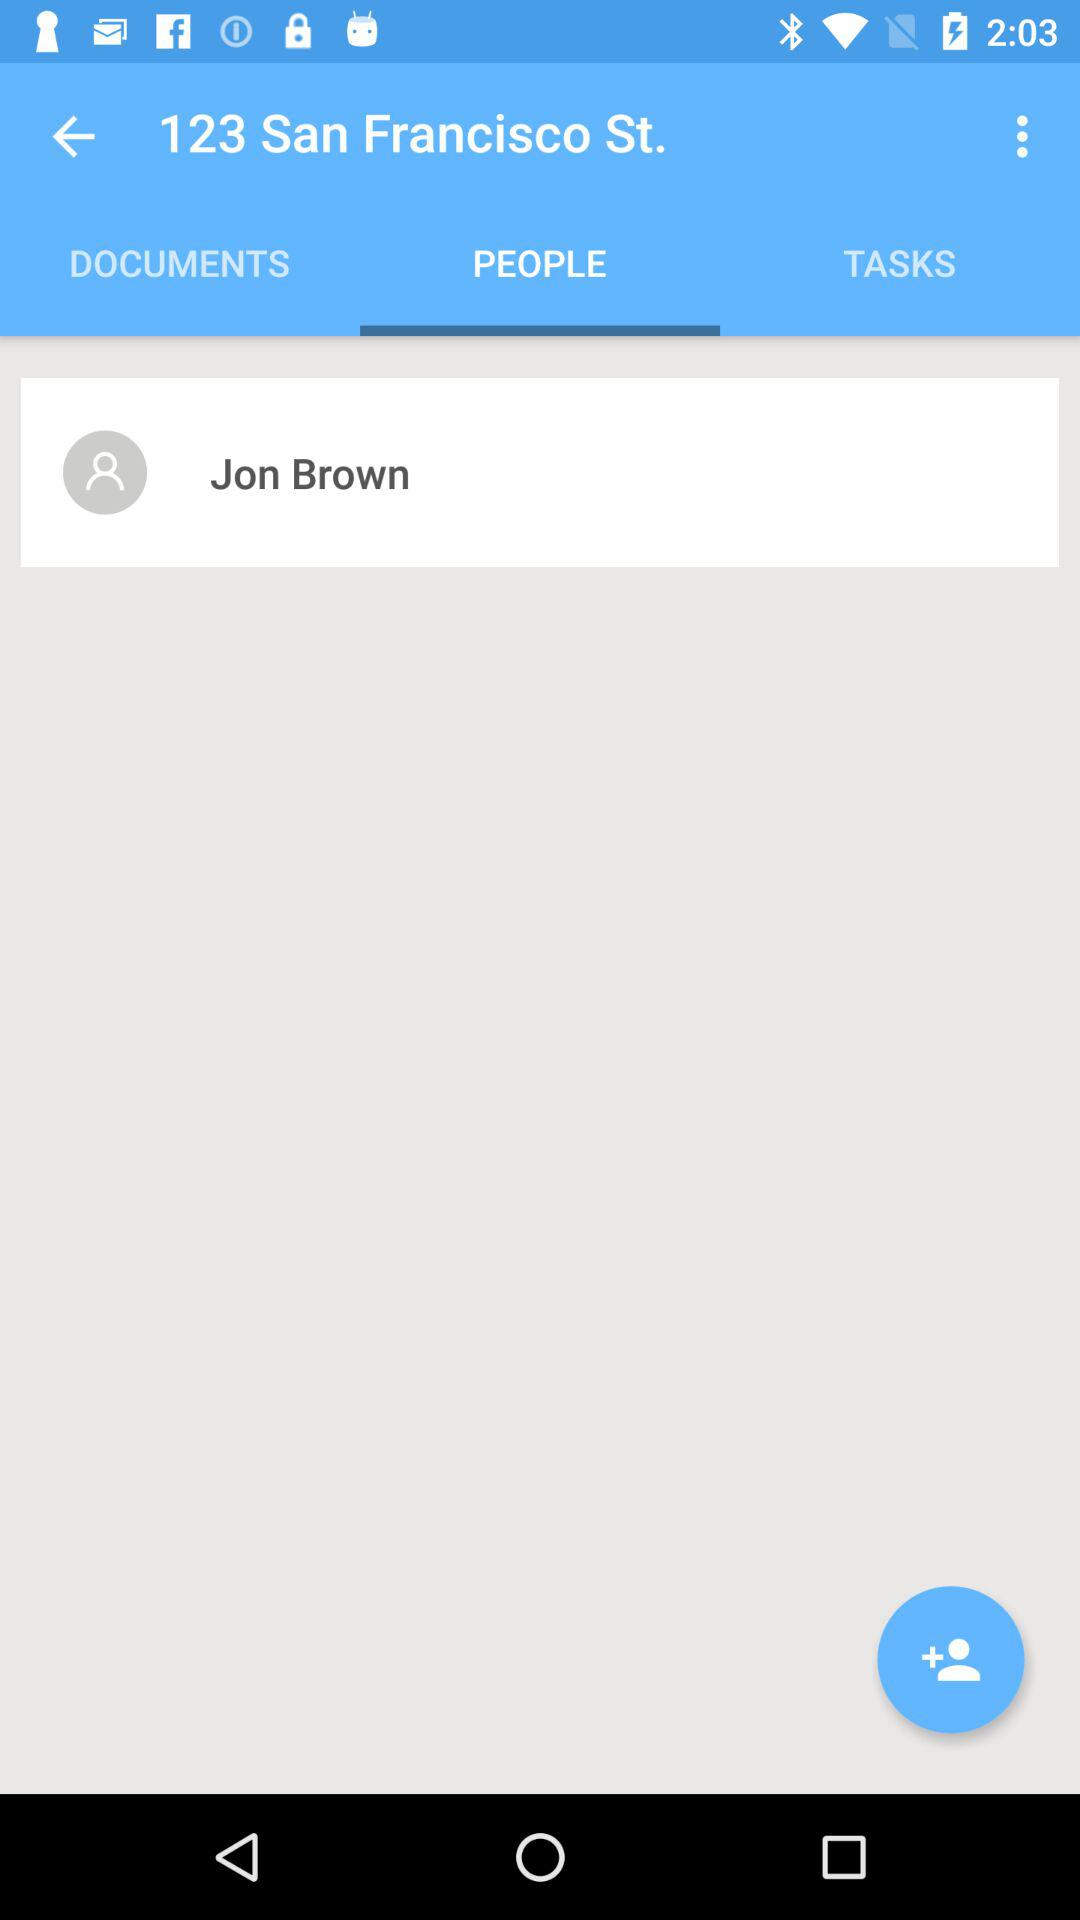Which tab has been selected? The selected tab is "PEOPLE". 